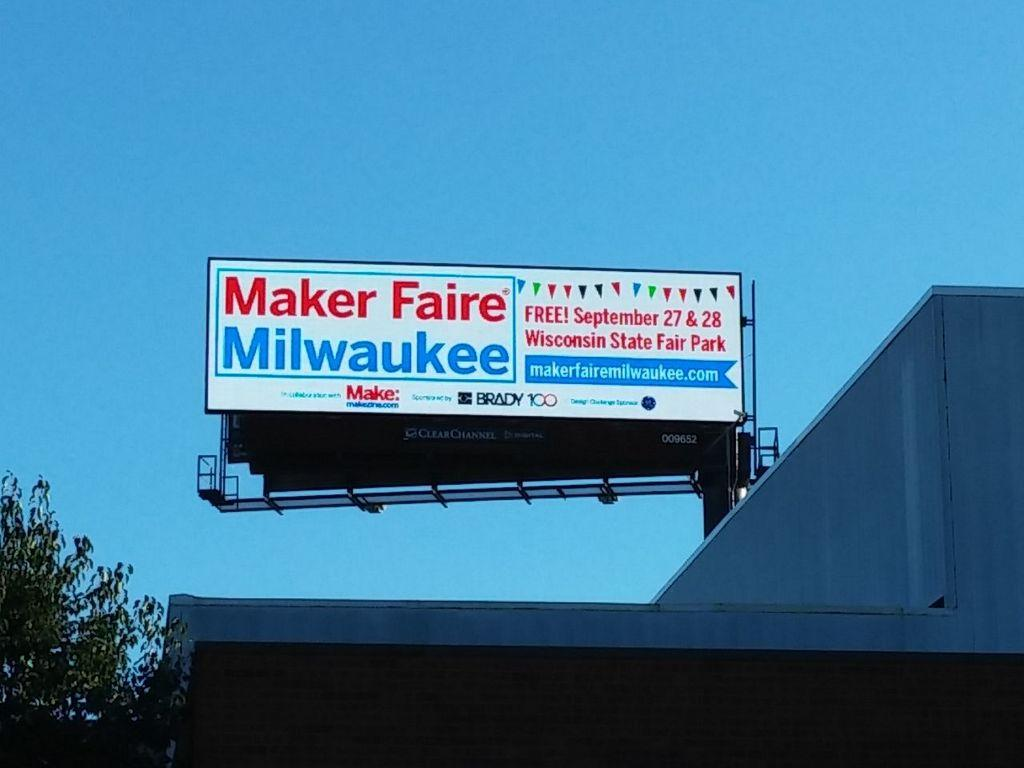<image>
Give a short and clear explanation of the subsequent image. A sign advertising a free fair in Milwaukee. 